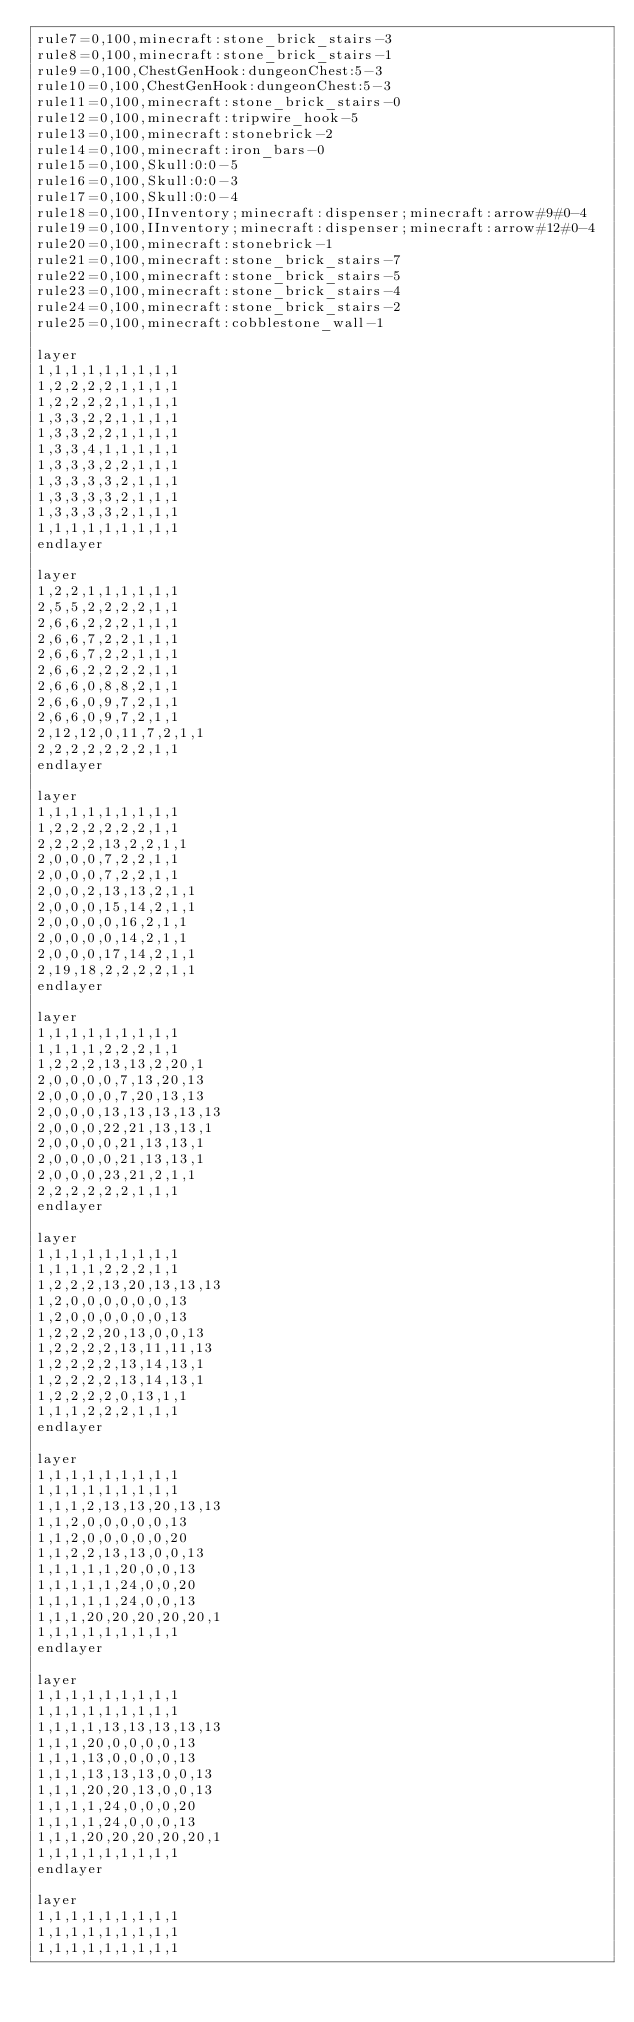Convert code to text. <code><loc_0><loc_0><loc_500><loc_500><_XML_>rule7=0,100,minecraft:stone_brick_stairs-3
rule8=0,100,minecraft:stone_brick_stairs-1
rule9=0,100,ChestGenHook:dungeonChest:5-3
rule10=0,100,ChestGenHook:dungeonChest:5-3
rule11=0,100,minecraft:stone_brick_stairs-0
rule12=0,100,minecraft:tripwire_hook-5
rule13=0,100,minecraft:stonebrick-2
rule14=0,100,minecraft:iron_bars-0
rule15=0,100,Skull:0:0-5
rule16=0,100,Skull:0:0-3
rule17=0,100,Skull:0:0-4
rule18=0,100,IInventory;minecraft:dispenser;minecraft:arrow#9#0-4
rule19=0,100,IInventory;minecraft:dispenser;minecraft:arrow#12#0-4
rule20=0,100,minecraft:stonebrick-1
rule21=0,100,minecraft:stone_brick_stairs-7
rule22=0,100,minecraft:stone_brick_stairs-5
rule23=0,100,minecraft:stone_brick_stairs-4
rule24=0,100,minecraft:stone_brick_stairs-2
rule25=0,100,minecraft:cobblestone_wall-1

layer
1,1,1,1,1,1,1,1,1
1,2,2,2,2,1,1,1,1
1,2,2,2,2,1,1,1,1
1,3,3,2,2,1,1,1,1
1,3,3,2,2,1,1,1,1
1,3,3,4,1,1,1,1,1
1,3,3,3,2,2,1,1,1
1,3,3,3,3,2,1,1,1
1,3,3,3,3,2,1,1,1
1,3,3,3,3,2,1,1,1
1,1,1,1,1,1,1,1,1
endlayer

layer
1,2,2,1,1,1,1,1,1
2,5,5,2,2,2,2,1,1
2,6,6,2,2,2,1,1,1
2,6,6,7,2,2,1,1,1
2,6,6,7,2,2,1,1,1
2,6,6,2,2,2,2,1,1
2,6,6,0,8,8,2,1,1
2,6,6,0,9,7,2,1,1
2,6,6,0,9,7,2,1,1
2,12,12,0,11,7,2,1,1
2,2,2,2,2,2,2,1,1
endlayer

layer
1,1,1,1,1,1,1,1,1
1,2,2,2,2,2,2,1,1
2,2,2,2,13,2,2,1,1
2,0,0,0,7,2,2,1,1
2,0,0,0,7,2,2,1,1
2,0,0,2,13,13,2,1,1
2,0,0,0,15,14,2,1,1
2,0,0,0,0,16,2,1,1
2,0,0,0,0,14,2,1,1
2,0,0,0,17,14,2,1,1
2,19,18,2,2,2,2,1,1
endlayer

layer
1,1,1,1,1,1,1,1,1
1,1,1,1,2,2,2,1,1
1,2,2,2,13,13,2,20,1
2,0,0,0,0,7,13,20,13
2,0,0,0,0,7,20,13,13
2,0,0,0,13,13,13,13,13
2,0,0,0,22,21,13,13,1
2,0,0,0,0,21,13,13,1
2,0,0,0,0,21,13,13,1
2,0,0,0,23,21,2,1,1
2,2,2,2,2,2,1,1,1
endlayer

layer
1,1,1,1,1,1,1,1,1
1,1,1,1,2,2,2,1,1
1,2,2,2,13,20,13,13,13
1,2,0,0,0,0,0,0,13
1,2,0,0,0,0,0,0,13
1,2,2,2,20,13,0,0,13
1,2,2,2,2,13,11,11,13
1,2,2,2,2,13,14,13,1
1,2,2,2,2,13,14,13,1
1,2,2,2,2,0,13,1,1
1,1,1,2,2,2,1,1,1
endlayer

layer
1,1,1,1,1,1,1,1,1
1,1,1,1,1,1,1,1,1
1,1,1,2,13,13,20,13,13
1,1,2,0,0,0,0,0,13
1,1,2,0,0,0,0,0,20
1,1,2,2,13,13,0,0,13
1,1,1,1,1,20,0,0,13
1,1,1,1,1,24,0,0,20
1,1,1,1,1,24,0,0,13
1,1,1,20,20,20,20,20,1
1,1,1,1,1,1,1,1,1
endlayer

layer
1,1,1,1,1,1,1,1,1
1,1,1,1,1,1,1,1,1
1,1,1,1,13,13,13,13,13
1,1,1,20,0,0,0,0,13
1,1,1,13,0,0,0,0,13
1,1,1,13,13,13,0,0,13
1,1,1,20,20,13,0,0,13
1,1,1,1,24,0,0,0,20
1,1,1,1,24,0,0,0,13
1,1,1,20,20,20,20,20,1
1,1,1,1,1,1,1,1,1
endlayer

layer
1,1,1,1,1,1,1,1,1
1,1,1,1,1,1,1,1,1
1,1,1,1,1,1,1,1,1</code> 